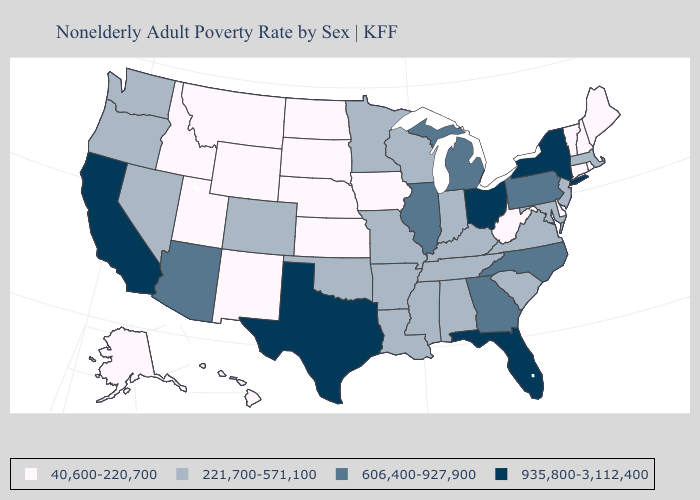Name the states that have a value in the range 40,600-220,700?
Answer briefly. Alaska, Connecticut, Delaware, Hawaii, Idaho, Iowa, Kansas, Maine, Montana, Nebraska, New Hampshire, New Mexico, North Dakota, Rhode Island, South Dakota, Utah, Vermont, West Virginia, Wyoming. What is the highest value in states that border Montana?
Short answer required. 40,600-220,700. Name the states that have a value in the range 40,600-220,700?
Be succinct. Alaska, Connecticut, Delaware, Hawaii, Idaho, Iowa, Kansas, Maine, Montana, Nebraska, New Hampshire, New Mexico, North Dakota, Rhode Island, South Dakota, Utah, Vermont, West Virginia, Wyoming. Does the map have missing data?
Concise answer only. No. What is the value of Delaware?
Concise answer only. 40,600-220,700. Which states have the highest value in the USA?
Be succinct. California, Florida, New York, Ohio, Texas. What is the value of Missouri?
Keep it brief. 221,700-571,100. Does Utah have a lower value than Delaware?
Keep it brief. No. Which states have the highest value in the USA?
Answer briefly. California, Florida, New York, Ohio, Texas. Name the states that have a value in the range 40,600-220,700?
Keep it brief. Alaska, Connecticut, Delaware, Hawaii, Idaho, Iowa, Kansas, Maine, Montana, Nebraska, New Hampshire, New Mexico, North Dakota, Rhode Island, South Dakota, Utah, Vermont, West Virginia, Wyoming. Does Nebraska have a lower value than Alaska?
Short answer required. No. What is the value of Hawaii?
Write a very short answer. 40,600-220,700. Name the states that have a value in the range 935,800-3,112,400?
Keep it brief. California, Florida, New York, Ohio, Texas. Name the states that have a value in the range 935,800-3,112,400?
Short answer required. California, Florida, New York, Ohio, Texas. Does Pennsylvania have the lowest value in the USA?
Be succinct. No. 